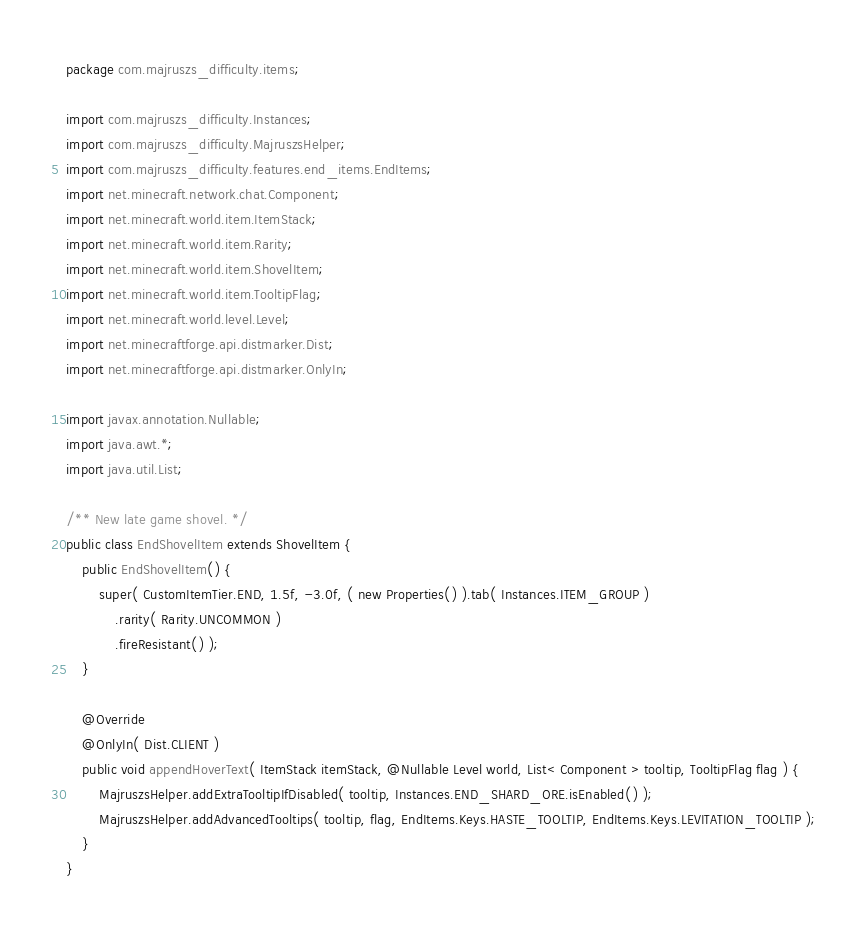<code> <loc_0><loc_0><loc_500><loc_500><_Java_>package com.majruszs_difficulty.items;

import com.majruszs_difficulty.Instances;
import com.majruszs_difficulty.MajruszsHelper;
import com.majruszs_difficulty.features.end_items.EndItems;
import net.minecraft.network.chat.Component;
import net.minecraft.world.item.ItemStack;
import net.minecraft.world.item.Rarity;
import net.minecraft.world.item.ShovelItem;
import net.minecraft.world.item.TooltipFlag;
import net.minecraft.world.level.Level;
import net.minecraftforge.api.distmarker.Dist;
import net.minecraftforge.api.distmarker.OnlyIn;

import javax.annotation.Nullable;
import java.awt.*;
import java.util.List;

/** New late game shovel. */
public class EndShovelItem extends ShovelItem {
	public EndShovelItem() {
		super( CustomItemTier.END, 1.5f, -3.0f, ( new Properties() ).tab( Instances.ITEM_GROUP )
			.rarity( Rarity.UNCOMMON )
			.fireResistant() );
	}

	@Override
	@OnlyIn( Dist.CLIENT )
	public void appendHoverText( ItemStack itemStack, @Nullable Level world, List< Component > tooltip, TooltipFlag flag ) {
		MajruszsHelper.addExtraTooltipIfDisabled( tooltip, Instances.END_SHARD_ORE.isEnabled() );
		MajruszsHelper.addAdvancedTooltips( tooltip, flag, EndItems.Keys.HASTE_TOOLTIP, EndItems.Keys.LEVITATION_TOOLTIP );
	}
}
</code> 